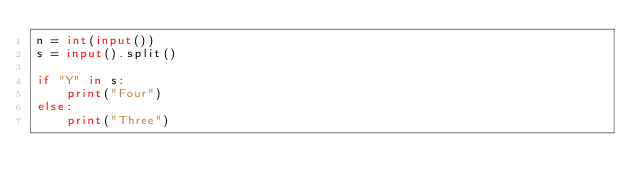<code> <loc_0><loc_0><loc_500><loc_500><_Python_>n = int(input())
s = input().split()

if "Y" in s:
    print("Four")
else:
    print("Three")</code> 